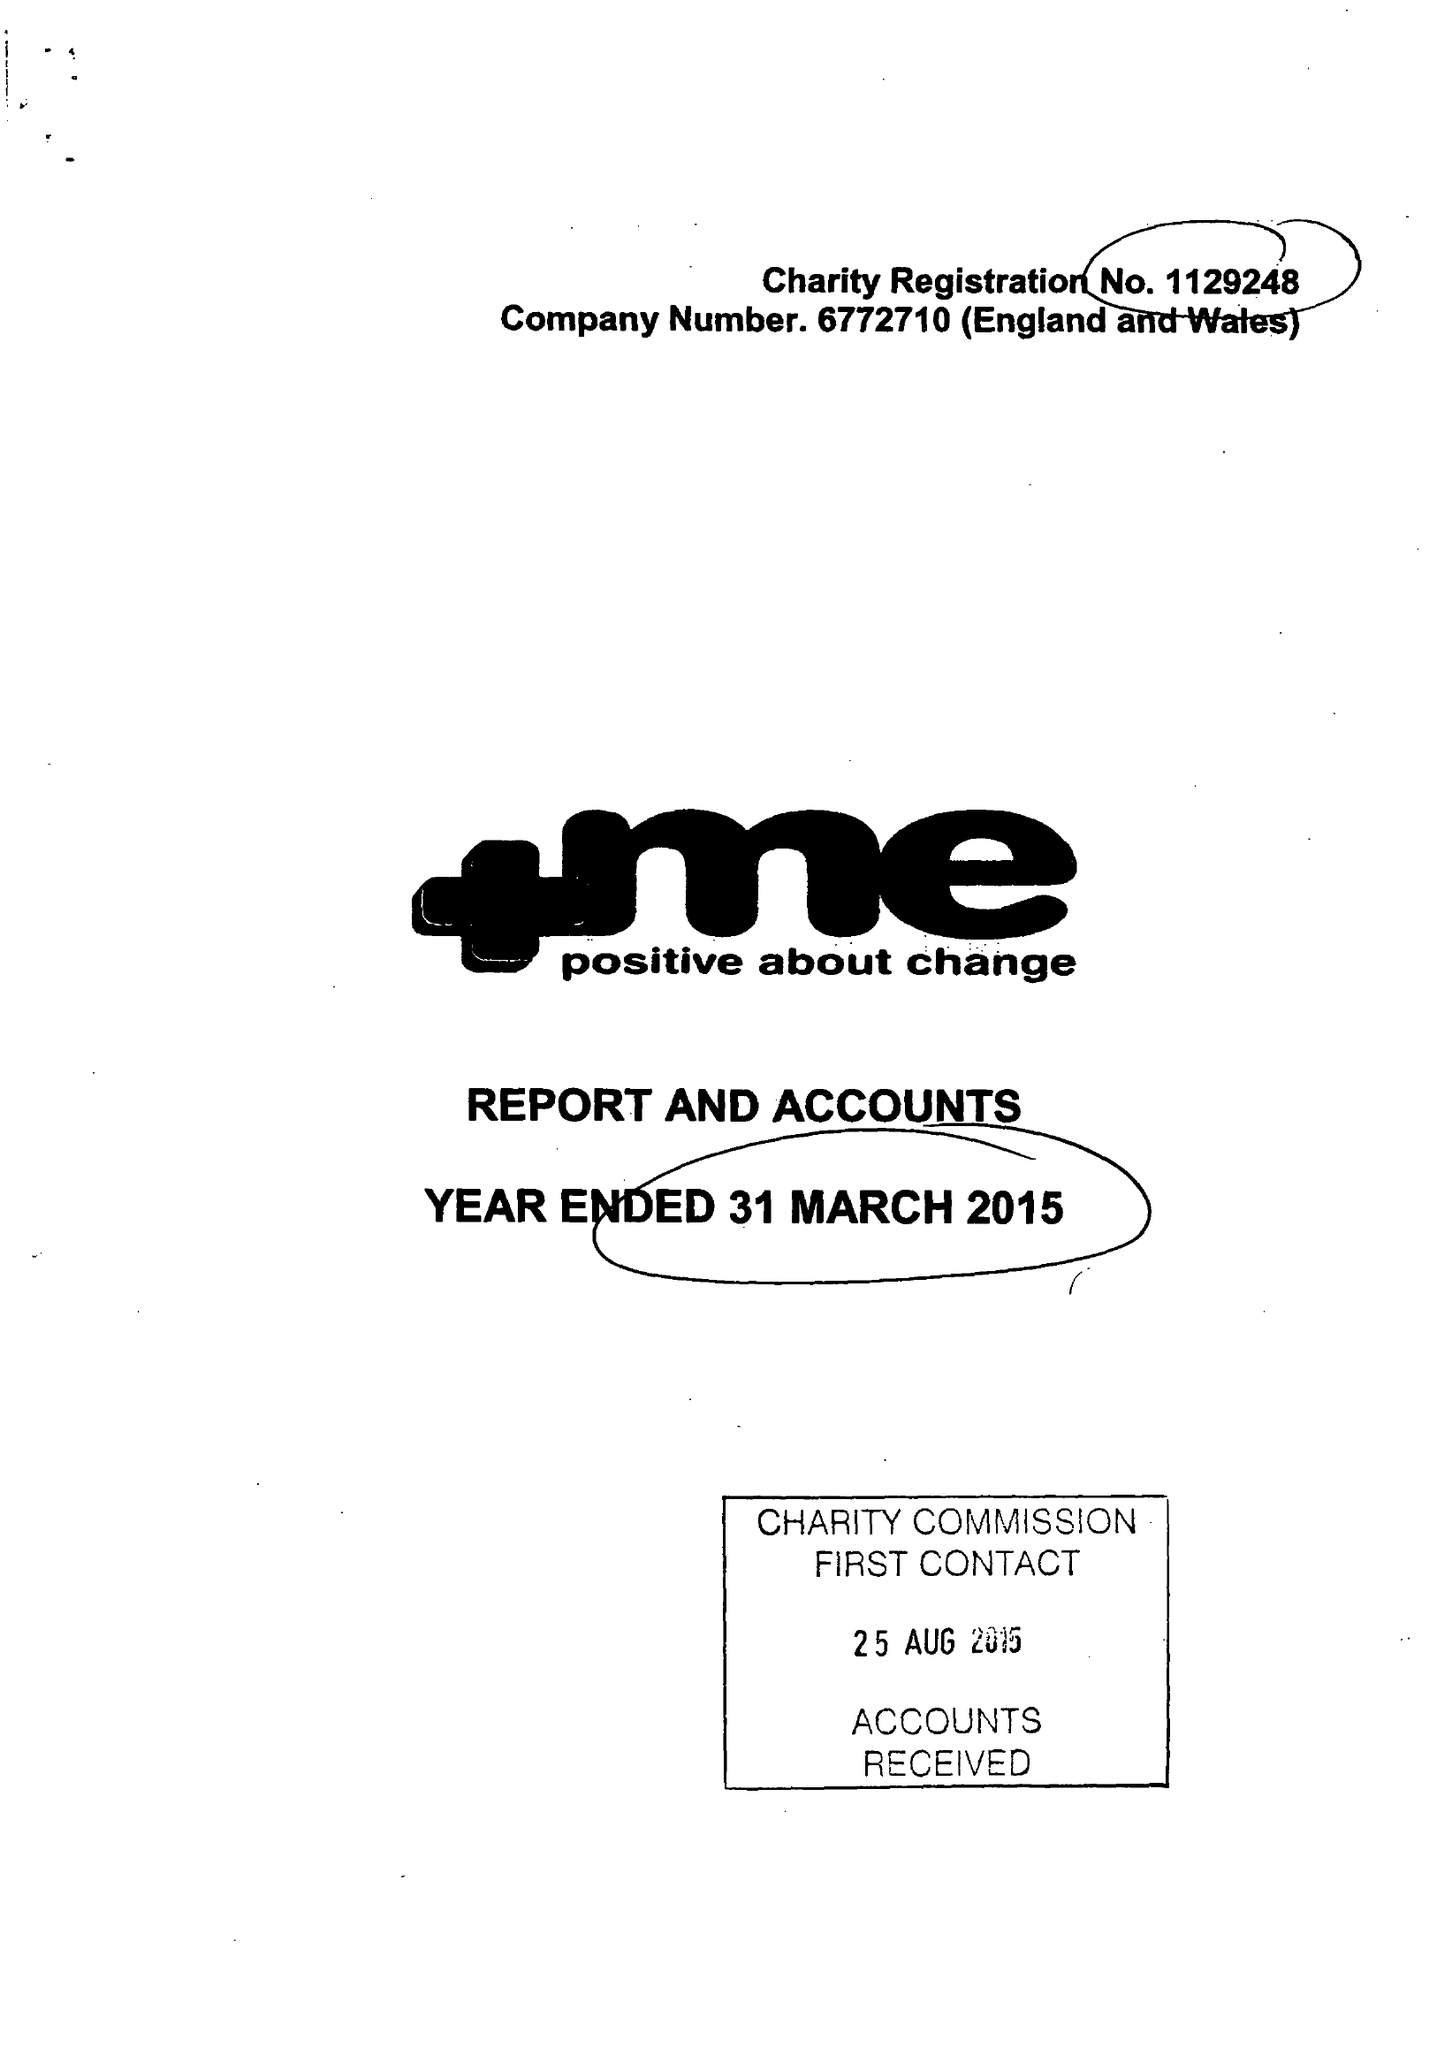What is the value for the address__postcode?
Answer the question using a single word or phrase. S71 1AN 